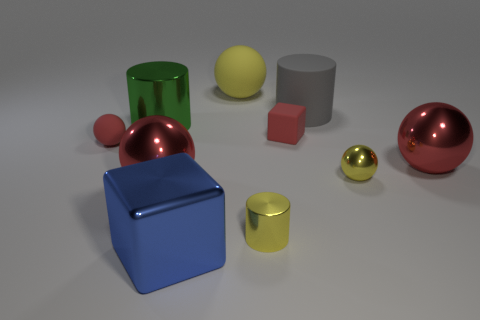What number of red blocks are left of the small sphere that is left of the large blue metal thing?
Your answer should be very brief. 0. What number of big cubes are the same material as the yellow cylinder?
Give a very brief answer. 1. There is a small red matte ball; are there any big green objects behind it?
Give a very brief answer. Yes. The rubber thing that is the same size as the rubber cylinder is what color?
Your response must be concise. Yellow. How many objects are either big metal balls to the right of the tiny red cube or tiny cyan matte blocks?
Keep it short and to the point. 1. There is a matte thing that is both to the left of the large rubber cylinder and behind the large green cylinder; what is its size?
Your answer should be compact. Large. What is the size of the matte ball that is the same color as the matte cube?
Ensure brevity in your answer.  Small. How many other objects are the same size as the green metal cylinder?
Give a very brief answer. 5. What color is the tiny metal thing left of the block that is behind the yellow sphere in front of the green shiny object?
Offer a terse response. Yellow. The object that is both behind the tiny metal ball and right of the gray rubber cylinder has what shape?
Make the answer very short. Sphere. 